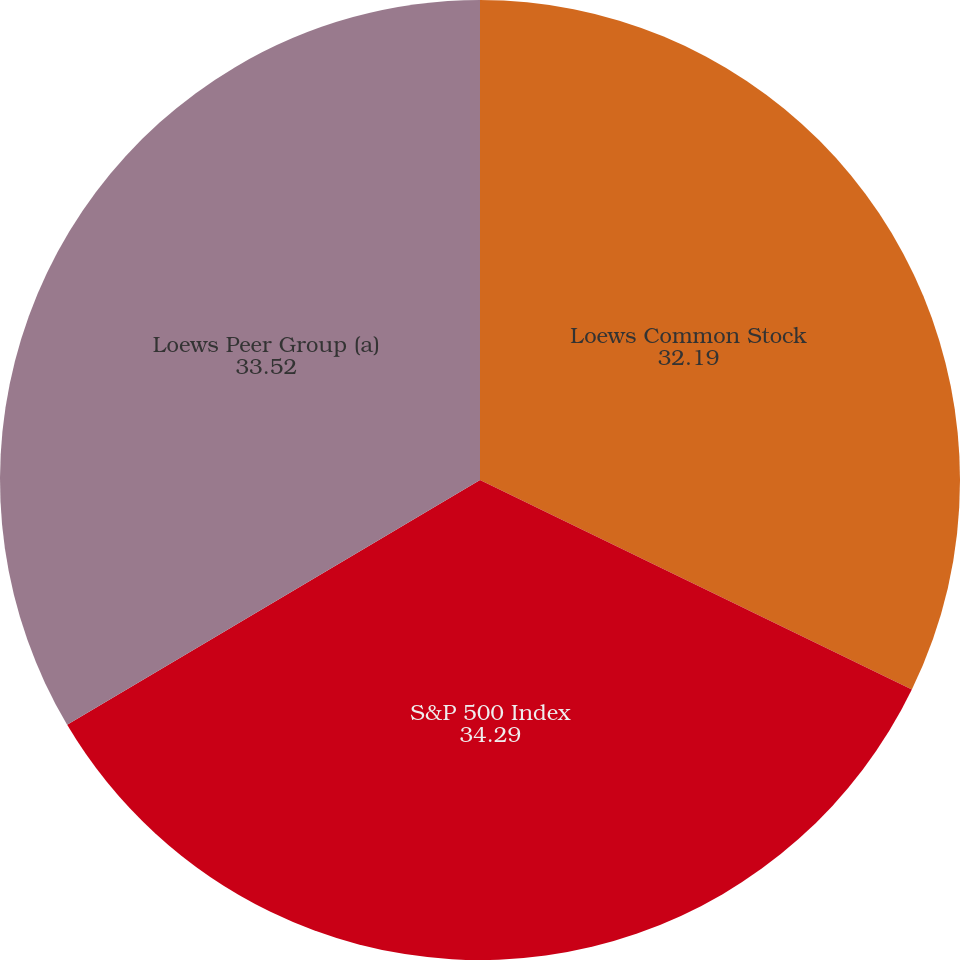Convert chart to OTSL. <chart><loc_0><loc_0><loc_500><loc_500><pie_chart><fcel>Loews Common Stock<fcel>S&P 500 Index<fcel>Loews Peer Group (a)<nl><fcel>32.19%<fcel>34.29%<fcel>33.52%<nl></chart> 